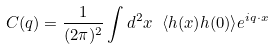<formula> <loc_0><loc_0><loc_500><loc_500>C ( q ) = \frac { 1 } { ( 2 \pi ) ^ { 2 } } \int d ^ { 2 } x \ \langle h ( { x } ) h ( { 0 } ) \rangle e ^ { i { q \cdot x } }</formula> 